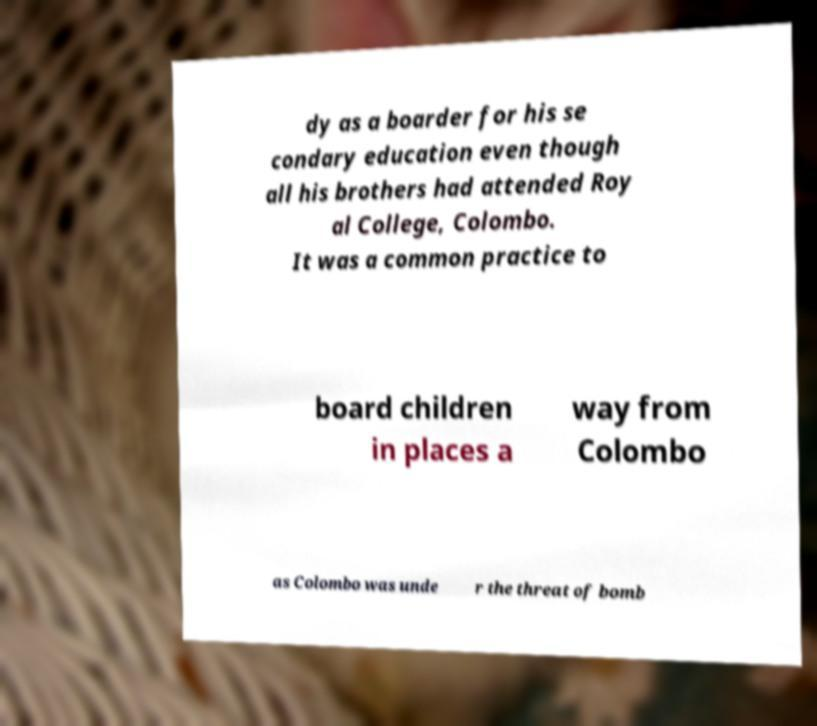Can you accurately transcribe the text from the provided image for me? dy as a boarder for his se condary education even though all his brothers had attended Roy al College, Colombo. It was a common practice to board children in places a way from Colombo as Colombo was unde r the threat of bomb 